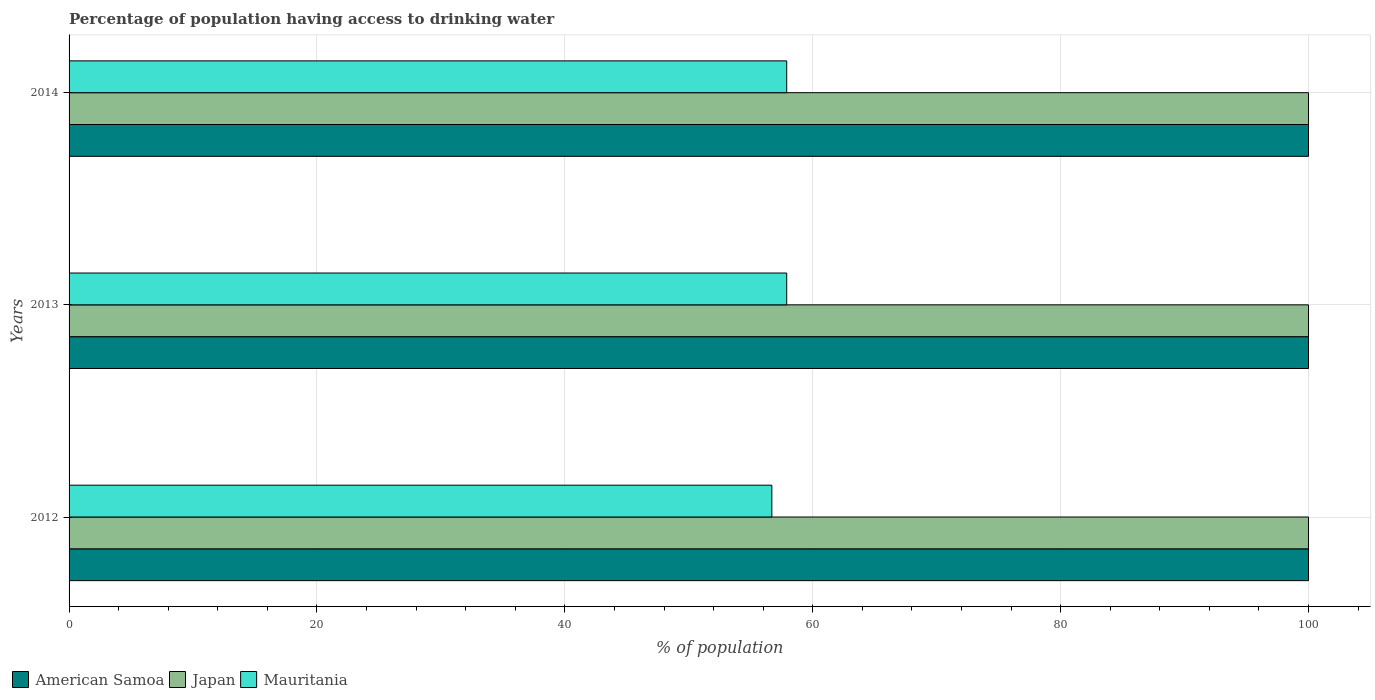How many different coloured bars are there?
Provide a succinct answer. 3. How many bars are there on the 2nd tick from the bottom?
Your answer should be compact. 3. What is the label of the 3rd group of bars from the top?
Offer a terse response. 2012. In how many cases, is the number of bars for a given year not equal to the number of legend labels?
Ensure brevity in your answer.  0. Across all years, what is the maximum percentage of population having access to drinking water in Japan?
Your answer should be compact. 100. Across all years, what is the minimum percentage of population having access to drinking water in American Samoa?
Give a very brief answer. 100. In which year was the percentage of population having access to drinking water in Japan minimum?
Provide a short and direct response. 2012. What is the total percentage of population having access to drinking water in Japan in the graph?
Your answer should be very brief. 300. What is the difference between the percentage of population having access to drinking water in American Samoa in 2012 and that in 2014?
Give a very brief answer. 0. What is the difference between the percentage of population having access to drinking water in Japan in 2013 and the percentage of population having access to drinking water in American Samoa in 2012?
Make the answer very short. 0. What is the average percentage of population having access to drinking water in Mauritania per year?
Offer a very short reply. 57.5. In how many years, is the percentage of population having access to drinking water in American Samoa greater than 52 %?
Keep it short and to the point. 3. What is the ratio of the percentage of population having access to drinking water in Mauritania in 2012 to that in 2013?
Ensure brevity in your answer.  0.98. Is the percentage of population having access to drinking water in Japan in 2013 less than that in 2014?
Give a very brief answer. No. Is the difference between the percentage of population having access to drinking water in Japan in 2012 and 2013 greater than the difference between the percentage of population having access to drinking water in American Samoa in 2012 and 2013?
Make the answer very short. No. What is the difference between the highest and the lowest percentage of population having access to drinking water in Mauritania?
Ensure brevity in your answer.  1.2. What does the 1st bar from the top in 2014 represents?
Offer a very short reply. Mauritania. What does the 3rd bar from the bottom in 2013 represents?
Make the answer very short. Mauritania. Is it the case that in every year, the sum of the percentage of population having access to drinking water in Japan and percentage of population having access to drinking water in American Samoa is greater than the percentage of population having access to drinking water in Mauritania?
Your response must be concise. Yes. How many years are there in the graph?
Give a very brief answer. 3. What is the difference between two consecutive major ticks on the X-axis?
Provide a short and direct response. 20. Does the graph contain any zero values?
Make the answer very short. No. Does the graph contain grids?
Your answer should be compact. Yes. Where does the legend appear in the graph?
Keep it short and to the point. Bottom left. How many legend labels are there?
Provide a succinct answer. 3. How are the legend labels stacked?
Give a very brief answer. Horizontal. What is the title of the graph?
Provide a short and direct response. Percentage of population having access to drinking water. What is the label or title of the X-axis?
Make the answer very short. % of population. What is the label or title of the Y-axis?
Provide a succinct answer. Years. What is the % of population of American Samoa in 2012?
Your response must be concise. 100. What is the % of population of Japan in 2012?
Your response must be concise. 100. What is the % of population in Mauritania in 2012?
Provide a succinct answer. 56.7. What is the % of population in Japan in 2013?
Ensure brevity in your answer.  100. What is the % of population of Mauritania in 2013?
Ensure brevity in your answer.  57.9. What is the % of population of American Samoa in 2014?
Your response must be concise. 100. What is the % of population in Mauritania in 2014?
Provide a short and direct response. 57.9. Across all years, what is the maximum % of population in Japan?
Keep it short and to the point. 100. Across all years, what is the maximum % of population in Mauritania?
Your response must be concise. 57.9. Across all years, what is the minimum % of population in American Samoa?
Offer a terse response. 100. Across all years, what is the minimum % of population of Japan?
Make the answer very short. 100. Across all years, what is the minimum % of population of Mauritania?
Provide a succinct answer. 56.7. What is the total % of population in American Samoa in the graph?
Provide a short and direct response. 300. What is the total % of population of Japan in the graph?
Make the answer very short. 300. What is the total % of population in Mauritania in the graph?
Provide a succinct answer. 172.5. What is the difference between the % of population in American Samoa in 2012 and that in 2013?
Your answer should be compact. 0. What is the difference between the % of population in Japan in 2012 and that in 2013?
Ensure brevity in your answer.  0. What is the difference between the % of population in Mauritania in 2012 and that in 2013?
Offer a terse response. -1.2. What is the difference between the % of population in Japan in 2012 and that in 2014?
Ensure brevity in your answer.  0. What is the difference between the % of population in Mauritania in 2012 and that in 2014?
Give a very brief answer. -1.2. What is the difference between the % of population in Japan in 2013 and that in 2014?
Offer a terse response. 0. What is the difference between the % of population of American Samoa in 2012 and the % of population of Mauritania in 2013?
Provide a short and direct response. 42.1. What is the difference between the % of population in Japan in 2012 and the % of population in Mauritania in 2013?
Provide a short and direct response. 42.1. What is the difference between the % of population of American Samoa in 2012 and the % of population of Mauritania in 2014?
Your response must be concise. 42.1. What is the difference between the % of population of Japan in 2012 and the % of population of Mauritania in 2014?
Ensure brevity in your answer.  42.1. What is the difference between the % of population in American Samoa in 2013 and the % of population in Mauritania in 2014?
Offer a very short reply. 42.1. What is the difference between the % of population of Japan in 2013 and the % of population of Mauritania in 2014?
Make the answer very short. 42.1. What is the average % of population of Mauritania per year?
Your answer should be very brief. 57.5. In the year 2012, what is the difference between the % of population of American Samoa and % of population of Mauritania?
Your answer should be very brief. 43.3. In the year 2012, what is the difference between the % of population of Japan and % of population of Mauritania?
Ensure brevity in your answer.  43.3. In the year 2013, what is the difference between the % of population of American Samoa and % of population of Japan?
Provide a short and direct response. 0. In the year 2013, what is the difference between the % of population in American Samoa and % of population in Mauritania?
Your answer should be very brief. 42.1. In the year 2013, what is the difference between the % of population in Japan and % of population in Mauritania?
Offer a terse response. 42.1. In the year 2014, what is the difference between the % of population in American Samoa and % of population in Mauritania?
Your response must be concise. 42.1. In the year 2014, what is the difference between the % of population of Japan and % of population of Mauritania?
Keep it short and to the point. 42.1. What is the ratio of the % of population of Japan in 2012 to that in 2013?
Provide a short and direct response. 1. What is the ratio of the % of population of Mauritania in 2012 to that in 2013?
Give a very brief answer. 0.98. What is the ratio of the % of population in Mauritania in 2012 to that in 2014?
Provide a succinct answer. 0.98. What is the ratio of the % of population of Mauritania in 2013 to that in 2014?
Offer a terse response. 1. What is the difference between the highest and the lowest % of population in Japan?
Make the answer very short. 0. What is the difference between the highest and the lowest % of population in Mauritania?
Ensure brevity in your answer.  1.2. 